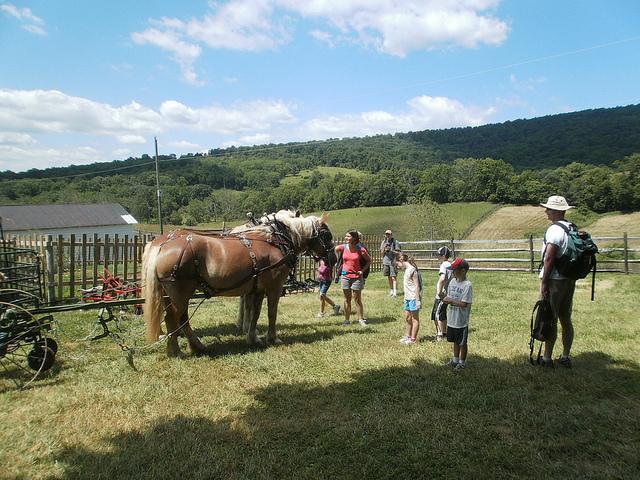What color is the horse without a rider?
Give a very brief answer. Brown. What is the woman doing?
Give a very brief answer. Petting horse. How many people can be seen?
Be succinct. 7. Is that a woman in the red shirt?
Be succinct. Yes. Is the little boy afraid of the horse?
Short answer required. No. What are the horses in?
Keep it brief. Harness. Is that horse wild?
Be succinct. No. Where is the man walking?
Concise answer only. In field. What animal is present?
Give a very brief answer. Horse. 